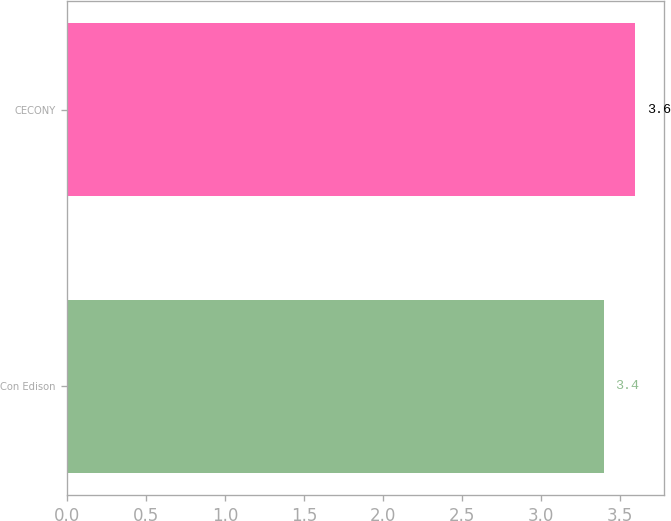Convert chart. <chart><loc_0><loc_0><loc_500><loc_500><bar_chart><fcel>Con Edison<fcel>CECONY<nl><fcel>3.4<fcel>3.6<nl></chart> 